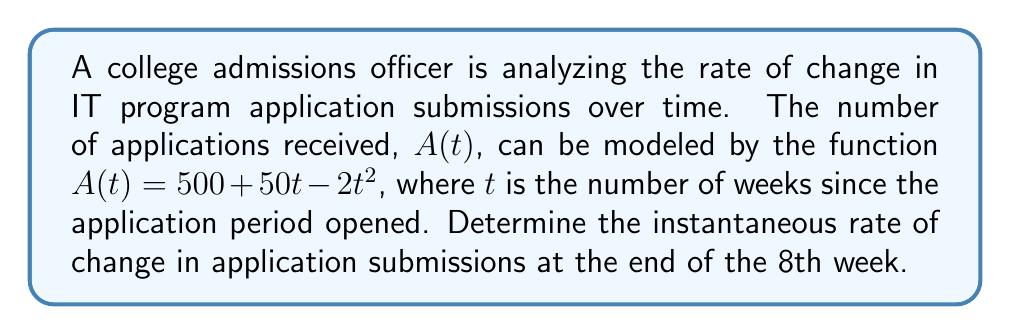Help me with this question. To solve this problem, we need to find the derivative of the function $A(t)$ and then evaluate it at $t = 8$. This will give us the instantaneous rate of change at the specified time.

Step 1: Find the derivative of $A(t)$
$A(t) = 500 + 50t - 2t^2$
$A'(t) = 50 - 4t$ (using the power rule and constant rule of differentiation)

Step 2: Evaluate $A'(t)$ at $t = 8$
$A'(8) = 50 - 4(8)$
$A'(8) = 50 - 32$
$A'(8) = 18$

The instantaneous rate of change is 18 applications per week at the end of the 8th week.

Interpretation: The positive value indicates that the number of applications is still increasing at this point, but the rate of increase is slowing down (as evident from the negative coefficient of $t$ in the derivative).
Answer: The instantaneous rate of change in IT program application submissions at the end of the 8th week is 18 applications per week. 